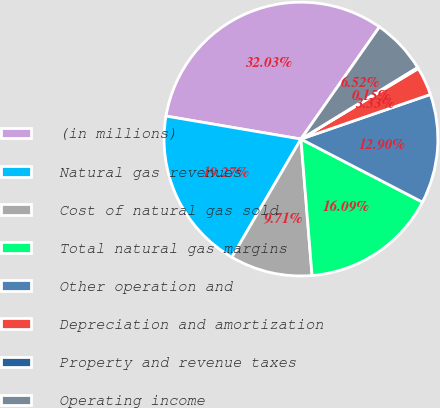<chart> <loc_0><loc_0><loc_500><loc_500><pie_chart><fcel>(in millions)<fcel>Natural gas revenues<fcel>Cost of natural gas sold<fcel>Total natural gas margins<fcel>Other operation and<fcel>Depreciation and amortization<fcel>Property and revenue taxes<fcel>Operating income<nl><fcel>32.03%<fcel>19.27%<fcel>9.71%<fcel>16.09%<fcel>12.9%<fcel>3.33%<fcel>0.15%<fcel>6.52%<nl></chart> 